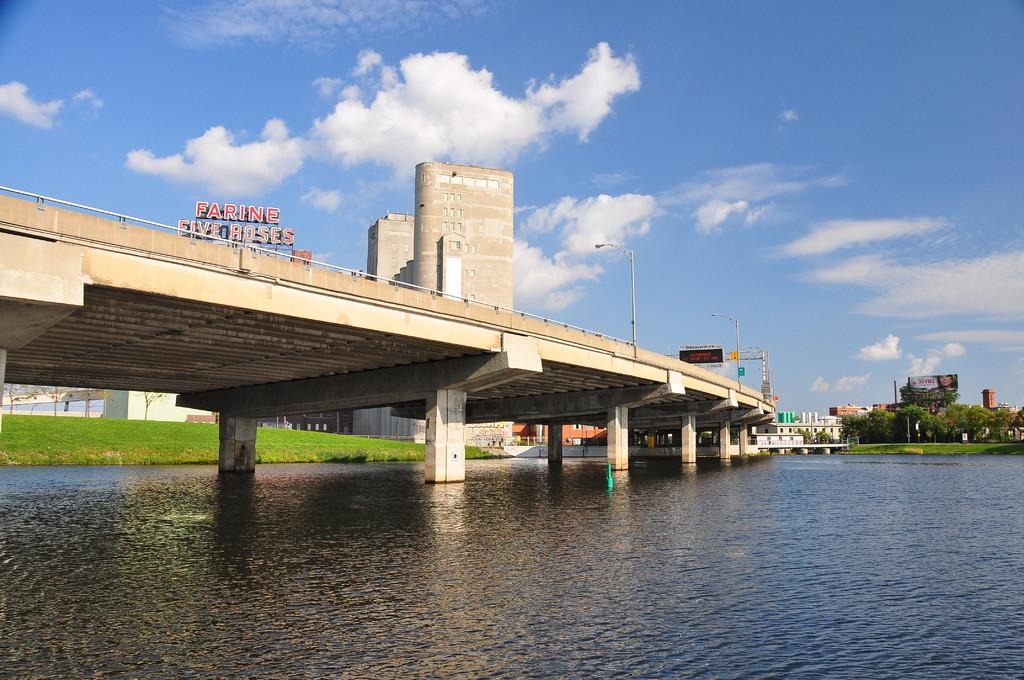What type of terrain is visible in the image? There is grass in the image, which suggests a natural, outdoor setting. What body of water can be seen in the image? There is water in the image, which could be a river, lake, or pond. What structures are present in the image? There are bridges, poles, and buildings visible in the image. What type of vegetation is present in the image? There are trees in the image, in addition to the grass. What additional object can be seen in the image? There is a banner in the image. What is visible in the background of the image? The sky is visible in the background of the image, with clouds present. What type of coil is used to hold the oranges in the image? There are no oranges or coils present in the image. What type of vessel is being used to transport the water in the image? There is no vessel visible in the image; the water is simply present in the environment. 